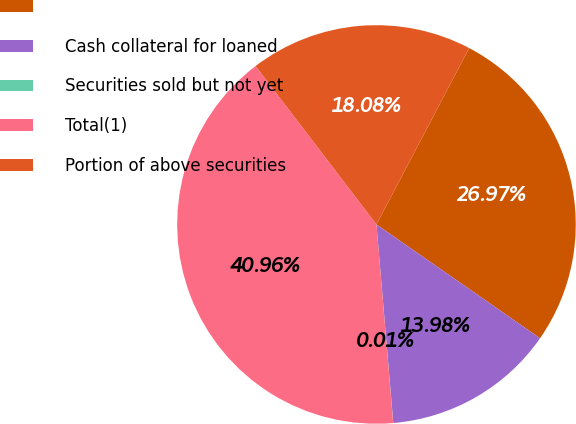Convert chart. <chart><loc_0><loc_0><loc_500><loc_500><pie_chart><ecel><fcel>Cash collateral for loaned<fcel>Securities sold but not yet<fcel>Total(1)<fcel>Portion of above securities<nl><fcel>26.97%<fcel>13.98%<fcel>0.01%<fcel>40.96%<fcel>18.08%<nl></chart> 